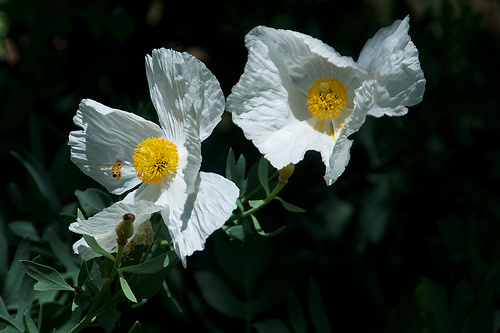<image>
Is the flower under the flower? No. The flower is not positioned under the flower. The vertical relationship between these objects is different. 